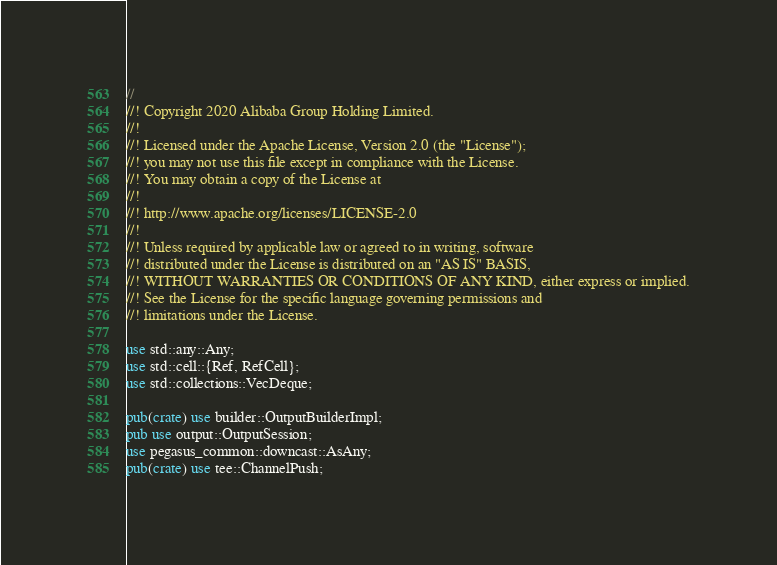Convert code to text. <code><loc_0><loc_0><loc_500><loc_500><_Rust_>//
//! Copyright 2020 Alibaba Group Holding Limited.
//!
//! Licensed under the Apache License, Version 2.0 (the "License");
//! you may not use this file except in compliance with the License.
//! You may obtain a copy of the License at
//!
//! http://www.apache.org/licenses/LICENSE-2.0
//!
//! Unless required by applicable law or agreed to in writing, software
//! distributed under the License is distributed on an "AS IS" BASIS,
//! WITHOUT WARRANTIES OR CONDITIONS OF ANY KIND, either express or implied.
//! See the License for the specific language governing permissions and
//! limitations under the License.

use std::any::Any;
use std::cell::{Ref, RefCell};
use std::collections::VecDeque;

pub(crate) use builder::OutputBuilderImpl;
pub use output::OutputSession;
use pegasus_common::downcast::AsAny;
pub(crate) use tee::ChannelPush;
</code> 